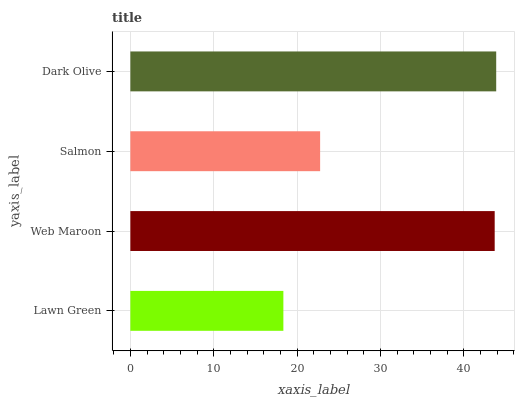Is Lawn Green the minimum?
Answer yes or no. Yes. Is Dark Olive the maximum?
Answer yes or no. Yes. Is Web Maroon the minimum?
Answer yes or no. No. Is Web Maroon the maximum?
Answer yes or no. No. Is Web Maroon greater than Lawn Green?
Answer yes or no. Yes. Is Lawn Green less than Web Maroon?
Answer yes or no. Yes. Is Lawn Green greater than Web Maroon?
Answer yes or no. No. Is Web Maroon less than Lawn Green?
Answer yes or no. No. Is Web Maroon the high median?
Answer yes or no. Yes. Is Salmon the low median?
Answer yes or no. Yes. Is Dark Olive the high median?
Answer yes or no. No. Is Web Maroon the low median?
Answer yes or no. No. 